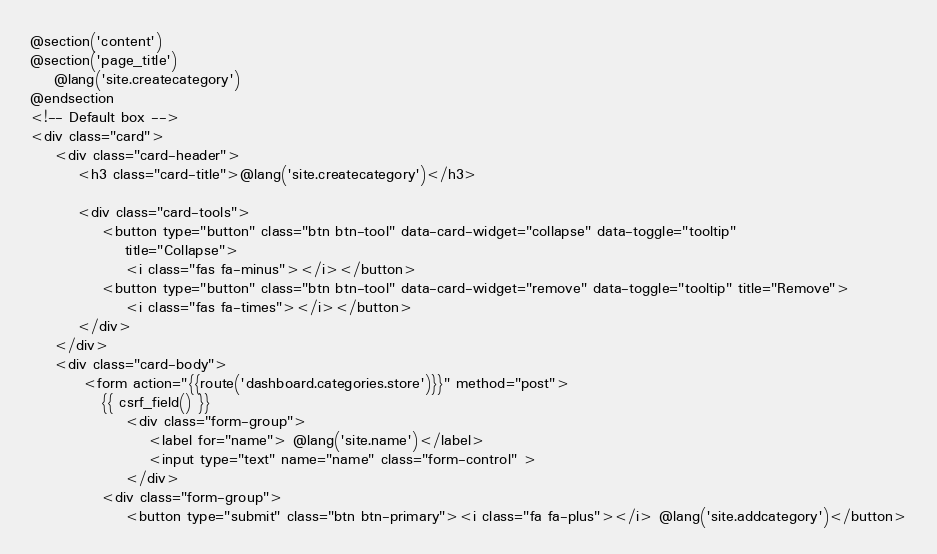Convert code to text. <code><loc_0><loc_0><loc_500><loc_500><_PHP_>@section('content')
@section('page_title')
    @lang('site.createcategory')
@endsection
<!-- Default box -->
<div class="card">
    <div class="card-header">
        <h3 class="card-title">@lang('site.createcategory')</h3>

        <div class="card-tools">
            <button type="button" class="btn btn-tool" data-card-widget="collapse" data-toggle="tooltip"
                title="Collapse">
                <i class="fas fa-minus"></i></button>
            <button type="button" class="btn btn-tool" data-card-widget="remove" data-toggle="tooltip" title="Remove">
                <i class="fas fa-times"></i></button>
        </div>
    </div>
    <div class="card-body">
         <form action="{{route('dashboard.categories.store')}}" method="post">
            {{ csrf_field() }}
                <div class="form-group">
                    <label for="name"> @lang('site.name')</label>
                    <input type="text" name="name" class="form-control" >
                </div>
            <div class="form-group">
                <button type="submit" class="btn btn-primary"><i class="fa fa-plus"></i> @lang('site.addcategory')</button></code> 